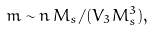Convert formula to latex. <formula><loc_0><loc_0><loc_500><loc_500>m \sim n \, M _ { s } / ( V _ { 3 } M _ { s } ^ { 3 } ) ,</formula> 